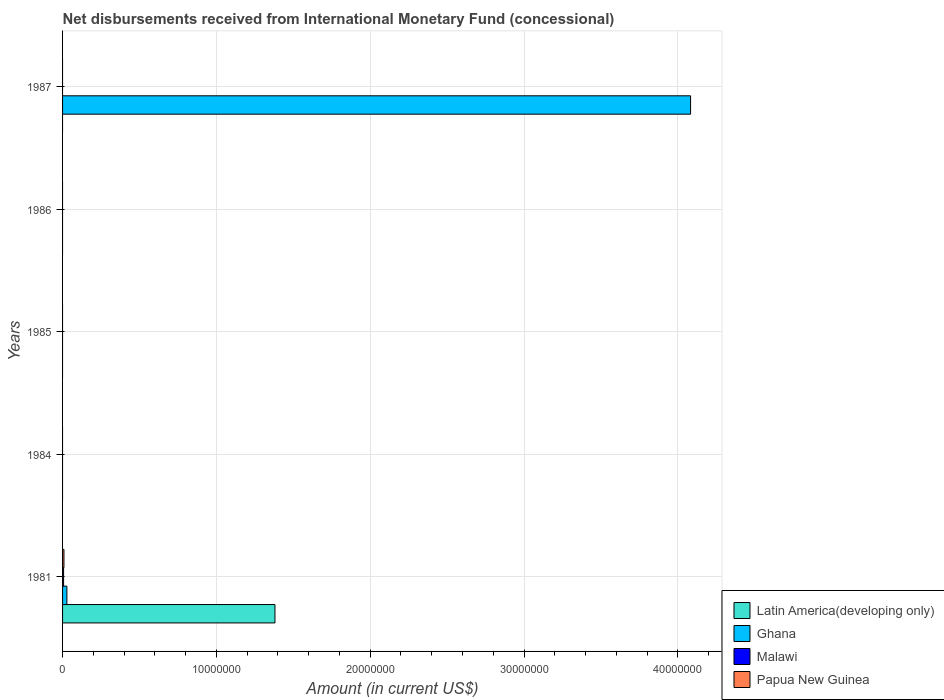How many different coloured bars are there?
Provide a short and direct response. 4. Are the number of bars on each tick of the Y-axis equal?
Offer a terse response. No. How many bars are there on the 4th tick from the top?
Give a very brief answer. 0. How many bars are there on the 3rd tick from the bottom?
Your response must be concise. 0. What is the label of the 3rd group of bars from the top?
Your answer should be compact. 1985. In how many cases, is the number of bars for a given year not equal to the number of legend labels?
Keep it short and to the point. 4. What is the amount of disbursements received from International Monetary Fund in Papua New Guinea in 1985?
Offer a terse response. 0. Across all years, what is the maximum amount of disbursements received from International Monetary Fund in Latin America(developing only)?
Make the answer very short. 1.38e+07. Across all years, what is the minimum amount of disbursements received from International Monetary Fund in Latin America(developing only)?
Offer a very short reply. 0. In which year was the amount of disbursements received from International Monetary Fund in Papua New Guinea maximum?
Ensure brevity in your answer.  1981. What is the total amount of disbursements received from International Monetary Fund in Malawi in the graph?
Provide a succinct answer. 6.70e+04. What is the difference between the amount of disbursements received from International Monetary Fund in Ghana in 1987 and the amount of disbursements received from International Monetary Fund in Latin America(developing only) in 1984?
Make the answer very short. 4.08e+07. What is the average amount of disbursements received from International Monetary Fund in Malawi per year?
Provide a short and direct response. 1.34e+04. In the year 1981, what is the difference between the amount of disbursements received from International Monetary Fund in Latin America(developing only) and amount of disbursements received from International Monetary Fund in Papua New Guinea?
Offer a terse response. 1.37e+07. What is the difference between the highest and the lowest amount of disbursements received from International Monetary Fund in Ghana?
Provide a succinct answer. 4.08e+07. In how many years, is the amount of disbursements received from International Monetary Fund in Ghana greater than the average amount of disbursements received from International Monetary Fund in Ghana taken over all years?
Provide a succinct answer. 1. Is it the case that in every year, the sum of the amount of disbursements received from International Monetary Fund in Latin America(developing only) and amount of disbursements received from International Monetary Fund in Malawi is greater than the amount of disbursements received from International Monetary Fund in Ghana?
Your answer should be very brief. No. How many bars are there?
Make the answer very short. 5. Are all the bars in the graph horizontal?
Ensure brevity in your answer.  Yes. Does the graph contain any zero values?
Offer a very short reply. Yes. What is the title of the graph?
Offer a very short reply. Net disbursements received from International Monetary Fund (concessional). Does "Ghana" appear as one of the legend labels in the graph?
Your answer should be compact. Yes. What is the label or title of the X-axis?
Offer a terse response. Amount (in current US$). What is the label or title of the Y-axis?
Ensure brevity in your answer.  Years. What is the Amount (in current US$) in Latin America(developing only) in 1981?
Keep it short and to the point. 1.38e+07. What is the Amount (in current US$) in Ghana in 1981?
Offer a very short reply. 2.81e+05. What is the Amount (in current US$) of Malawi in 1981?
Your answer should be compact. 6.70e+04. What is the Amount (in current US$) in Ghana in 1984?
Ensure brevity in your answer.  0. What is the Amount (in current US$) in Malawi in 1984?
Your answer should be compact. 0. What is the Amount (in current US$) of Papua New Guinea in 1984?
Give a very brief answer. 0. What is the Amount (in current US$) in Ghana in 1985?
Provide a short and direct response. 0. What is the Amount (in current US$) of Latin America(developing only) in 1987?
Your answer should be very brief. 0. What is the Amount (in current US$) of Ghana in 1987?
Provide a succinct answer. 4.08e+07. Across all years, what is the maximum Amount (in current US$) in Latin America(developing only)?
Offer a terse response. 1.38e+07. Across all years, what is the maximum Amount (in current US$) in Ghana?
Your response must be concise. 4.08e+07. Across all years, what is the maximum Amount (in current US$) of Malawi?
Make the answer very short. 6.70e+04. Across all years, what is the maximum Amount (in current US$) of Papua New Guinea?
Your answer should be compact. 9.00e+04. Across all years, what is the minimum Amount (in current US$) in Ghana?
Provide a succinct answer. 0. Across all years, what is the minimum Amount (in current US$) of Malawi?
Provide a short and direct response. 0. Across all years, what is the minimum Amount (in current US$) in Papua New Guinea?
Keep it short and to the point. 0. What is the total Amount (in current US$) of Latin America(developing only) in the graph?
Give a very brief answer. 1.38e+07. What is the total Amount (in current US$) of Ghana in the graph?
Keep it short and to the point. 4.11e+07. What is the total Amount (in current US$) of Malawi in the graph?
Your answer should be very brief. 6.70e+04. What is the total Amount (in current US$) in Papua New Guinea in the graph?
Ensure brevity in your answer.  9.00e+04. What is the difference between the Amount (in current US$) in Ghana in 1981 and that in 1987?
Your answer should be compact. -4.05e+07. What is the difference between the Amount (in current US$) in Latin America(developing only) in 1981 and the Amount (in current US$) in Ghana in 1987?
Your answer should be compact. -2.70e+07. What is the average Amount (in current US$) in Latin America(developing only) per year?
Keep it short and to the point. 2.76e+06. What is the average Amount (in current US$) of Ghana per year?
Offer a very short reply. 8.22e+06. What is the average Amount (in current US$) of Malawi per year?
Make the answer very short. 1.34e+04. What is the average Amount (in current US$) in Papua New Guinea per year?
Give a very brief answer. 1.80e+04. In the year 1981, what is the difference between the Amount (in current US$) of Latin America(developing only) and Amount (in current US$) of Ghana?
Keep it short and to the point. 1.35e+07. In the year 1981, what is the difference between the Amount (in current US$) of Latin America(developing only) and Amount (in current US$) of Malawi?
Provide a succinct answer. 1.37e+07. In the year 1981, what is the difference between the Amount (in current US$) in Latin America(developing only) and Amount (in current US$) in Papua New Guinea?
Ensure brevity in your answer.  1.37e+07. In the year 1981, what is the difference between the Amount (in current US$) in Ghana and Amount (in current US$) in Malawi?
Ensure brevity in your answer.  2.14e+05. In the year 1981, what is the difference between the Amount (in current US$) of Ghana and Amount (in current US$) of Papua New Guinea?
Your answer should be compact. 1.91e+05. In the year 1981, what is the difference between the Amount (in current US$) in Malawi and Amount (in current US$) in Papua New Guinea?
Give a very brief answer. -2.30e+04. What is the ratio of the Amount (in current US$) in Ghana in 1981 to that in 1987?
Offer a terse response. 0.01. What is the difference between the highest and the lowest Amount (in current US$) in Latin America(developing only)?
Offer a terse response. 1.38e+07. What is the difference between the highest and the lowest Amount (in current US$) of Ghana?
Your answer should be compact. 4.08e+07. What is the difference between the highest and the lowest Amount (in current US$) of Malawi?
Provide a succinct answer. 6.70e+04. 